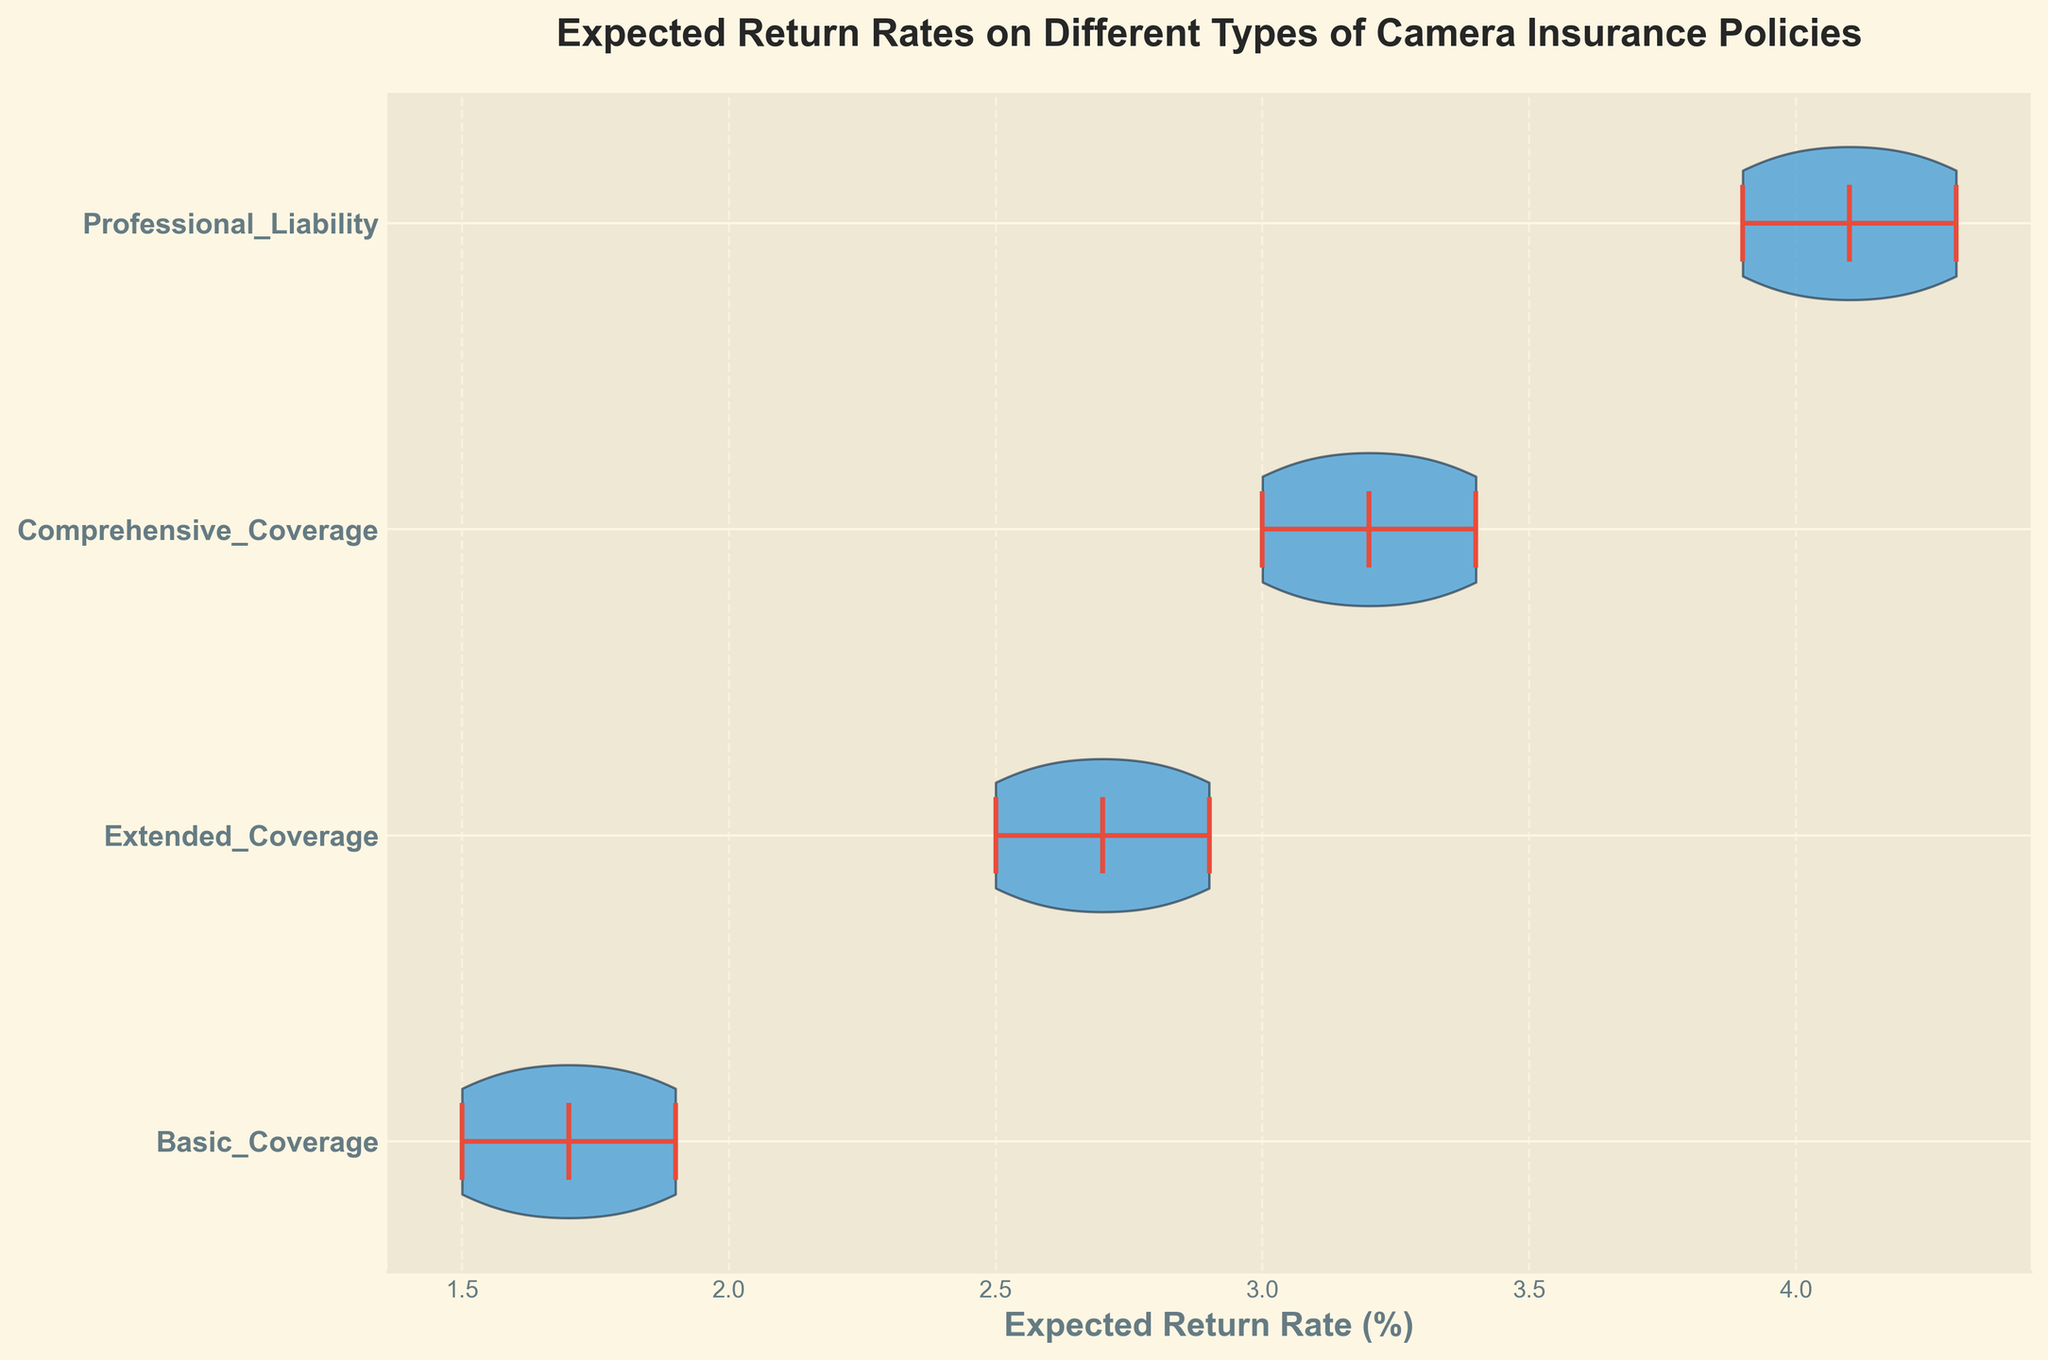What is the title of the figure? The title is usually found at the top of the chart and gives a summary of what the chart is about.
Answer: Expected Return Rates on Different Types of Camera Insurance Policies Which policy has the highest median expected return rate? In a violin plot, the median is often shown as a line in the middle of each distribution. The distribution with the highest median line is the answer.
Answer: Professional Liability What is the mean expected return rate for Extended Coverage? In a violin plot, the mean is typically shown with a marker, often a dot. Locate the mean marker for the "Extended Coverage" distribution to answer the question.
Answer: 2.7 Which policy shows the greatest variation in expected return rates? The spread or width of the violin plot indicates the variation. The broader the shape, the larger the range of data.
Answer: Professional Liability Between Basic Coverage and Comprehensive Coverage, which has a higher maximum expected return rate? The maximum value is typically indicated by the top of the distribution. Compare the maximum values of the respective distributions.
Answer: Comprehensive Coverage What are the expected return rates range for Basic Coverage? The range can be determined by looking at the extremities of the violin plot for Basic Coverage.
Answer: 1.5 to 1.9 Which coverage type shows a mean value closest to 3%? Compare the mean markers of each distribution to identify which one is closest to 3%.
Answer: Comprehensive Coverage How do the average return rates of Basic Coverage and Professional Liability compare? Check the mean markers for both Basic Coverage and Professional Liability and compare their values.
Answer: Professional Liability is higher What unique information does this type of chart (violin plot) convey? Violin plots show the density and distribution of data points, providing insight into variability, mean, median, and the overall range, all in one visual.
Answer: Data distribution and variability What is the y-label for this plot? The y-axis typically lists the categories or groups being compared in the violin plot.
Answer: Insurance_Policy 